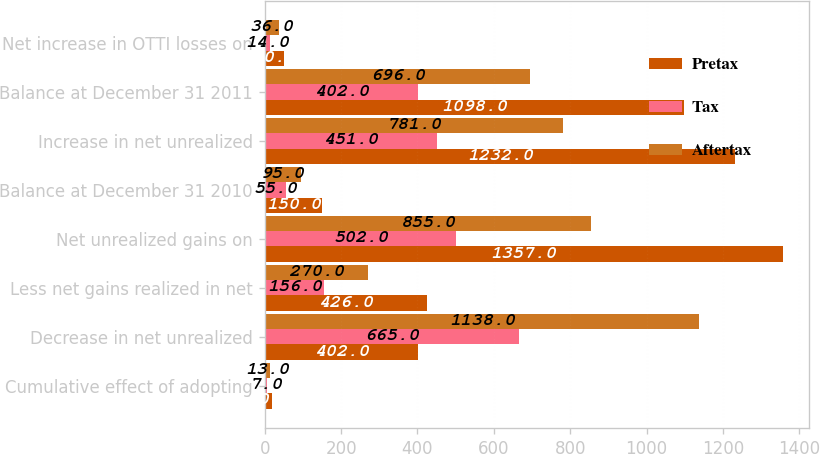Convert chart to OTSL. <chart><loc_0><loc_0><loc_500><loc_500><stacked_bar_chart><ecel><fcel>Cumulative effect of adopting<fcel>Decrease in net unrealized<fcel>Less net gains realized in net<fcel>Net unrealized gains on<fcel>Balance at December 31 2010<fcel>Increase in net unrealized<fcel>Balance at December 31 2011<fcel>Net increase in OTTI losses on<nl><fcel>Pretax<fcel>20<fcel>402<fcel>426<fcel>1357<fcel>150<fcel>1232<fcel>1098<fcel>50<nl><fcel>Tax<fcel>7<fcel>665<fcel>156<fcel>502<fcel>55<fcel>451<fcel>402<fcel>14<nl><fcel>Aftertax<fcel>13<fcel>1138<fcel>270<fcel>855<fcel>95<fcel>781<fcel>696<fcel>36<nl></chart> 